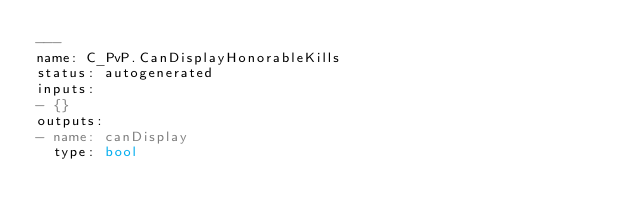<code> <loc_0><loc_0><loc_500><loc_500><_YAML_>---
name: C_PvP.CanDisplayHonorableKills
status: autogenerated
inputs:
- {}
outputs:
- name: canDisplay
  type: bool
</code> 